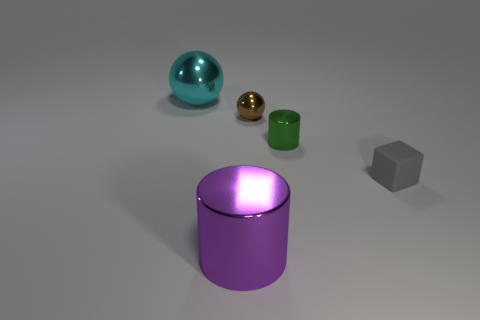The sphere that is on the right side of the big shiny thing that is behind the tiny cube is made of what material? The sphere on the right, which appears glossy and reflective, seems to be made of a material like polished metal or perhaps a metal alloy, typical for shiny, smooth materials that reflect their surroundings. 